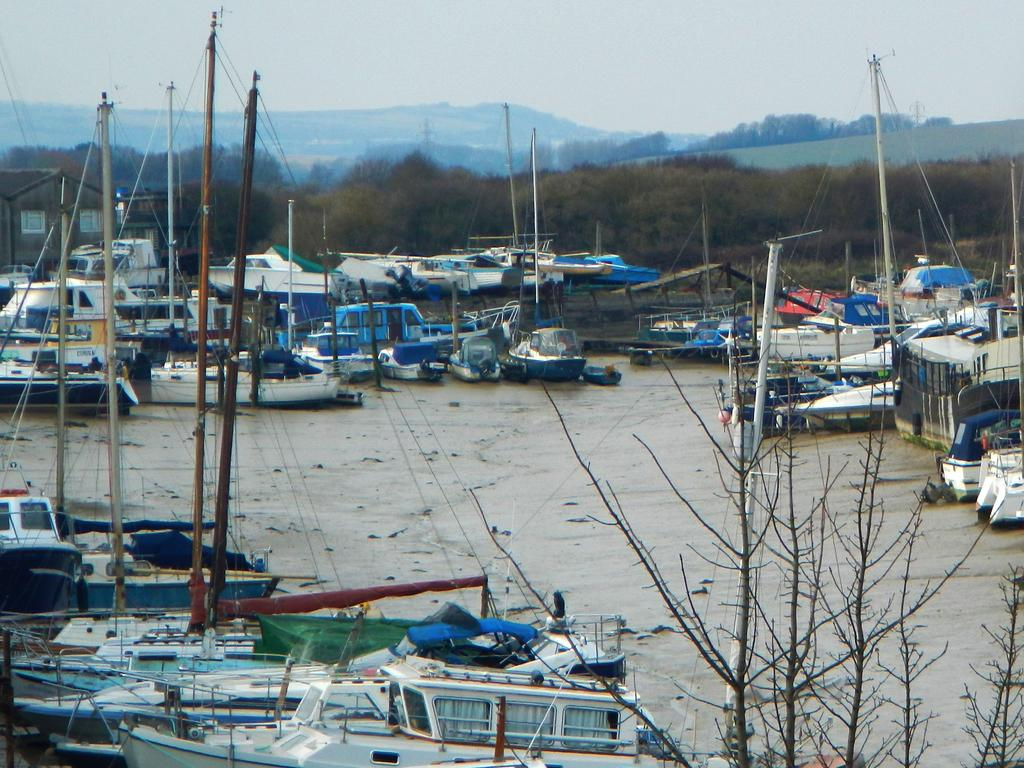What type of natural environment is depicted in the image? The image features a sea, trees, hills, and sky, indicating a coastal or beach setting. What types of watercraft are visible in the image? There are water crafts in the image, but their specific types cannot be determined from the facts provided. Can you describe the landscape in the image? The landscape includes trees, hills, and a sea, with sky visible above. What type of wax can be seen melting on the horn in the image? There is no wax or horn present in the image; it features a sea, trees, hills, and sky. 